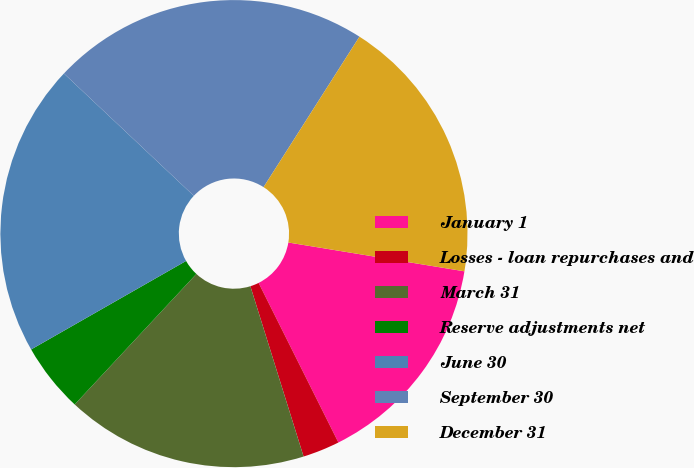Convert chart. <chart><loc_0><loc_0><loc_500><loc_500><pie_chart><fcel>January 1<fcel>Losses - loan repurchases and<fcel>March 31<fcel>Reserve adjustments net<fcel>June 30<fcel>September 30<fcel>December 31<nl><fcel>15.04%<fcel>2.56%<fcel>16.76%<fcel>4.8%<fcel>20.28%<fcel>22.01%<fcel>18.55%<nl></chart> 